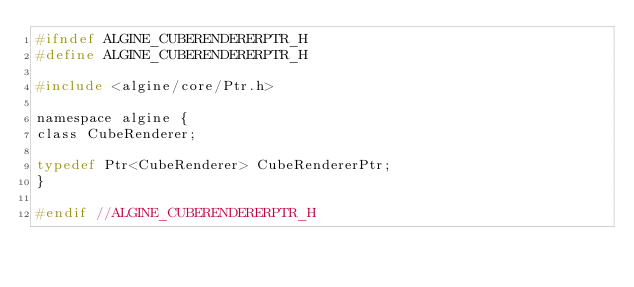<code> <loc_0><loc_0><loc_500><loc_500><_C_>#ifndef ALGINE_CUBERENDERERPTR_H
#define ALGINE_CUBERENDERERPTR_H

#include <algine/core/Ptr.h>

namespace algine {
class CubeRenderer;

typedef Ptr<CubeRenderer> CubeRendererPtr;
}

#endif //ALGINE_CUBERENDERERPTR_H
</code> 